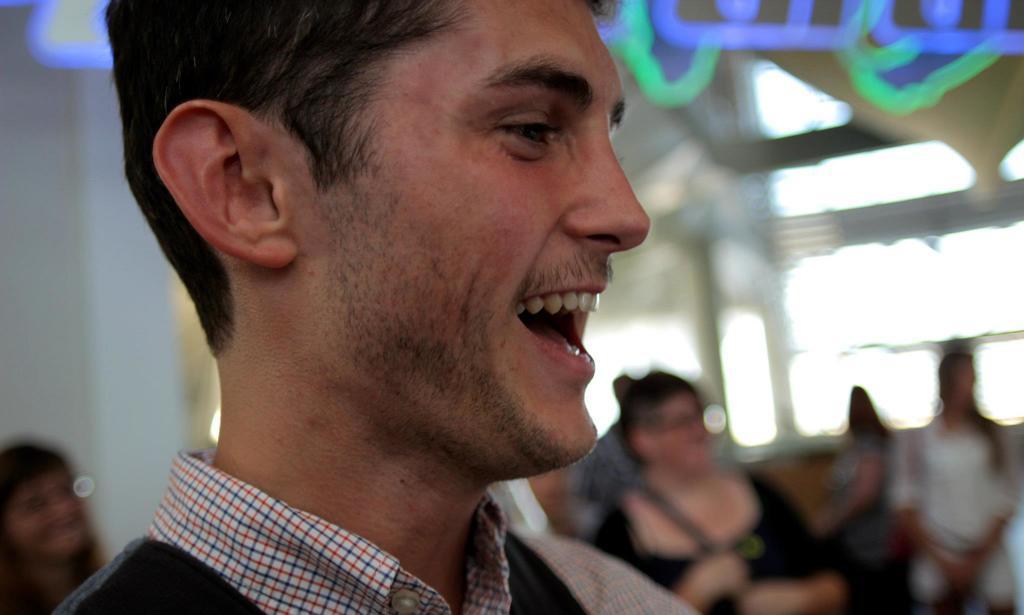In one or two sentences, can you explain what this image depicts? In this image we can see a man laughing. In the background we can see walls, windows, handles and crowd. 